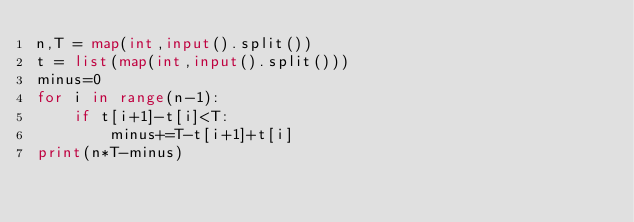<code> <loc_0><loc_0><loc_500><loc_500><_Python_>n,T = map(int,input().split())	
t = list(map(int,input().split()))
minus=0
for i in range(n-1):
    if t[i+1]-t[i]<T:
        minus+=T-t[i+1]+t[i]
print(n*T-minus)



</code> 